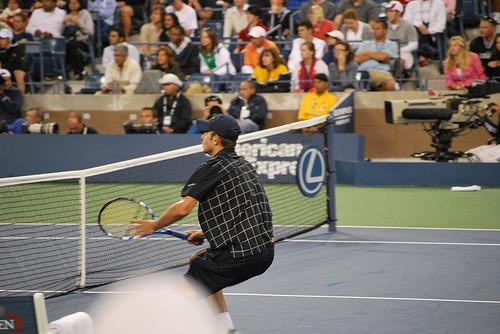Provide a brief summary of the attire and accessories sported by the main subject of the image. The man is wearing a black hat, black and white shirt, black shorts, and holds a blue and white tennis racket. Mention the key activity taking place in the image, along with the key participant and location. A person is playing tennis in a match on a blue tennis court. Can you tell what color shirt the woman spectating the match is wearing? The woman spectating the match is wearing a pink shirt. Approximately how many people are watching the tennis match in the image? It is not possible to determine the exact number of spectators watching the match from the available information. Identify the emblem found on the tennis net and its main colors. There is a blue and white Lexus symbol on the tennis net. What kind of event is most likely to be featured in the image? The image is most likely featuring a tennis match. Identify the object being held by a man, along with its main colors. The man is holding a blue and white tennis racket. Please state the overall emotion or sentiment associated with the image. The overall sentiment of the image is energetic, competitive, and engaging. What is the dominant color of the tennis court in the image? The dominant color of the tennis court is blue. Describe the type of clothing worn by the man playing tennis. The man is wearing a black hat, black and white shirt, black shorts, while holding a tennis racket. Is there a large advertisement banner with a famous tennis player's face in the background? There is no mention of an advertisement banner, a famous tennis player, or a face other than the man playing tennis. This instruction combines multiple non-existent elements, making it even more misleading for the person trying to identify objects in the image. Find the small green frog sitting on the tennis net. No, it's not mentioned in the image. Can you spot the purple umbrella that the woman in the pink shirt is holding? The woman in the pink shirt is mentioned in the image, but there is no information regarding her holding a purple umbrella. This instruction would be misleading as it combines a real element with a non-existent one. Look for the bright red sports car parked near the tennis court. None of the captions mention a sports car anywhere in the image. Introducing a completely new object with no relation to the provided information would lead the person to search for something non-existent. Observe the graffiti on the wall behind the tennis players. Although there is a mention of the text on the wall, graffiti is never mentioned in the captions. This instruction would mislead a person into searching for a specific kind of artwork that is not present in the image. 